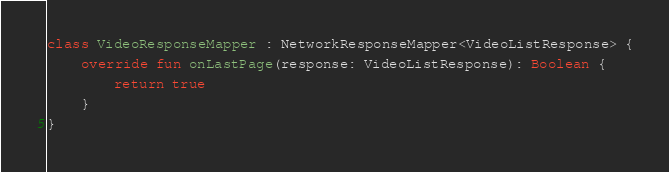<code> <loc_0><loc_0><loc_500><loc_500><_Kotlin_>
class VideoResponseMapper : NetworkResponseMapper<VideoListResponse> {
    override fun onLastPage(response: VideoListResponse): Boolean {
        return true
    }
}
</code> 